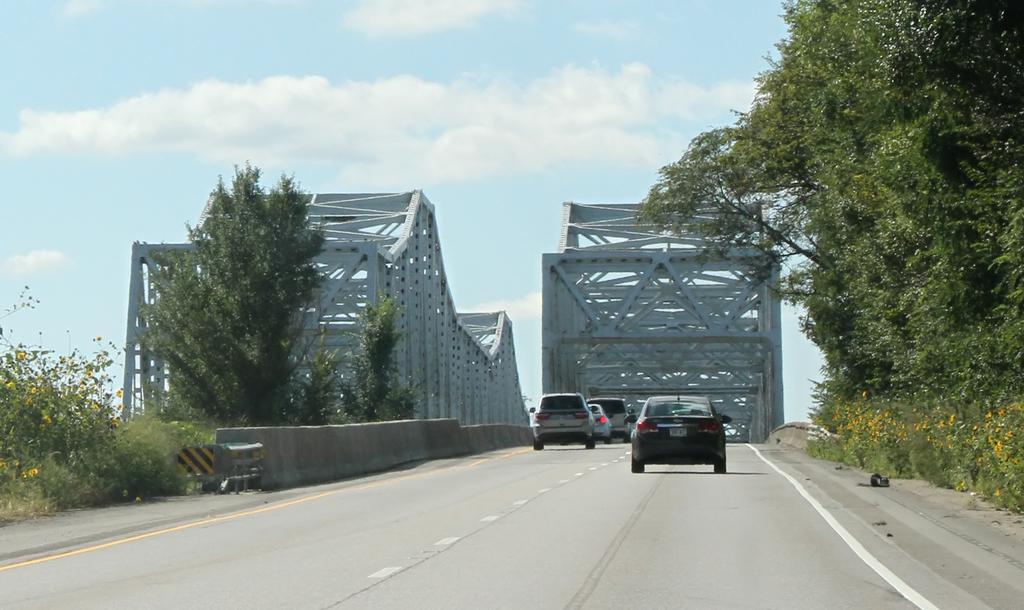Can you describe this image briefly? In this image we can see few vehicles on the road, there is a wall beside the road, there are few trees, iron railing and sky in the background. 